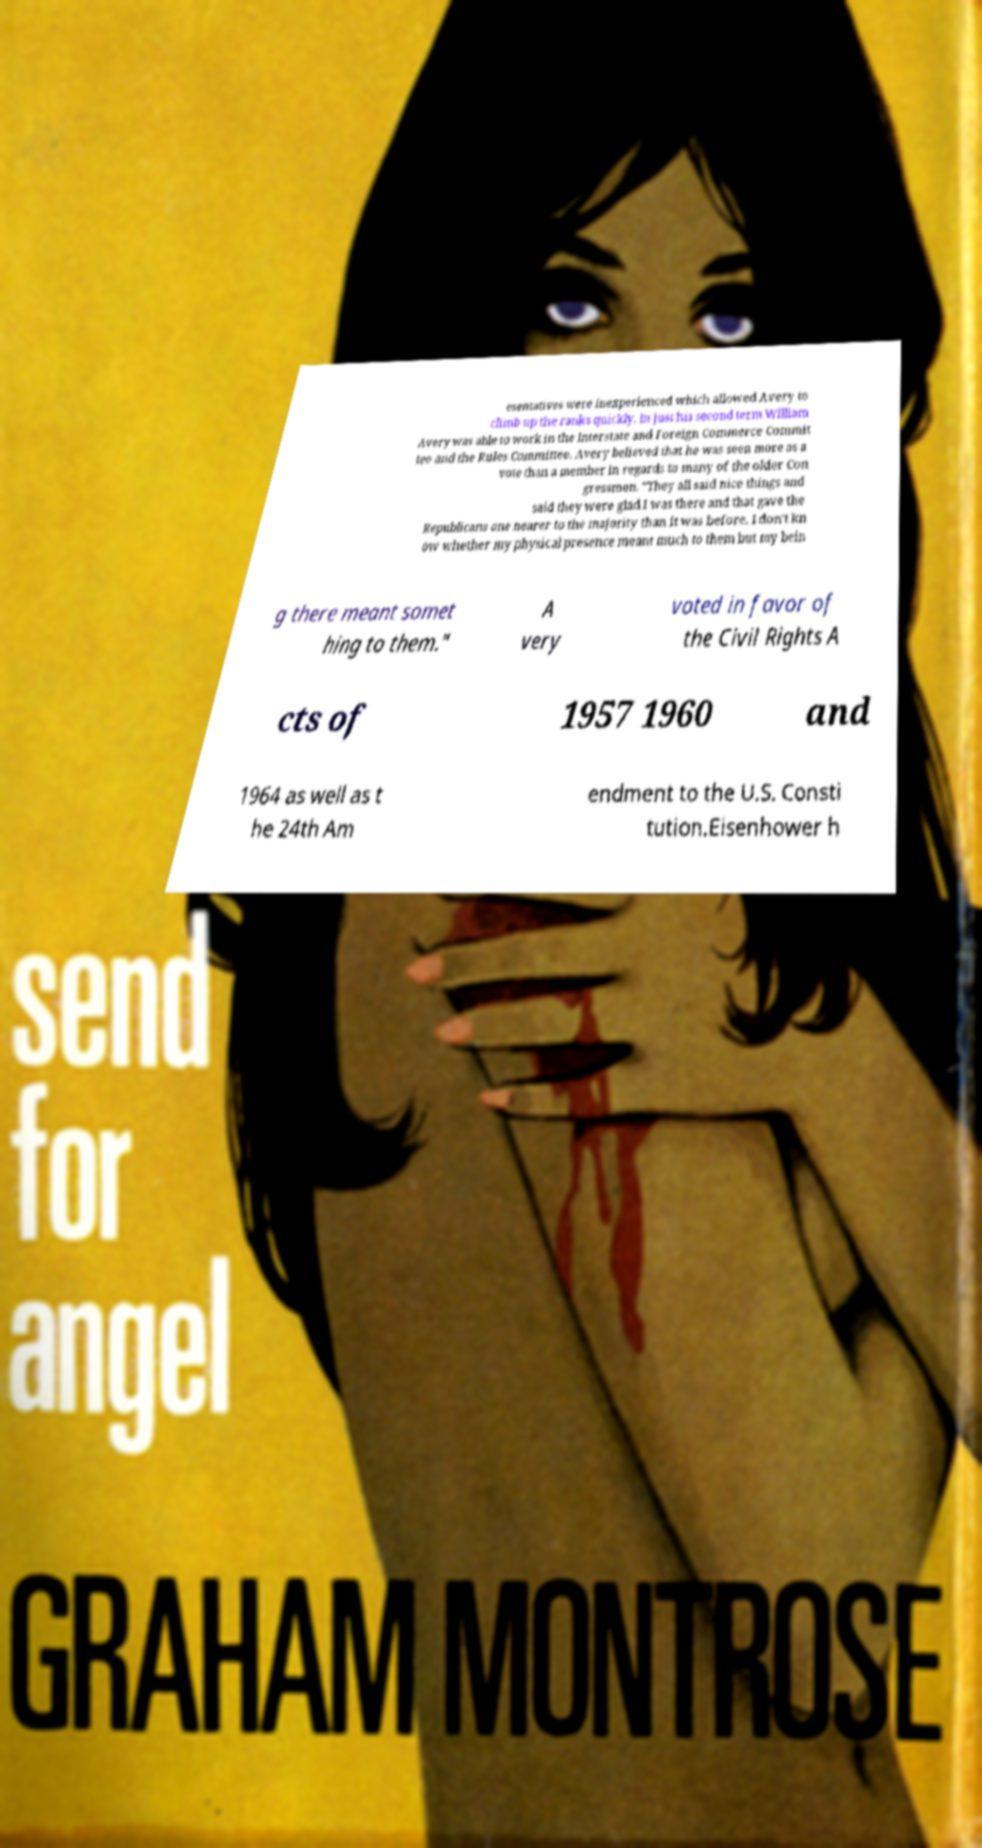There's text embedded in this image that I need extracted. Can you transcribe it verbatim? esentatives were inexperienced which allowed Avery to climb up the ranks quickly. In just his second term William Avery was able to work in the Interstate and Foreign Commerce Commit tee and the Rules Committee. Avery believed that he was seen more as a vote than a member in regards to many of the older Con gressmen. "They all said nice things and said they were glad I was there and that gave the Republicans one nearer to the majority than it was before. I don't kn ow whether my physical presence meant much to them but my bein g there meant somet hing to them." A very voted in favor of the Civil Rights A cts of 1957 1960 and 1964 as well as t he 24th Am endment to the U.S. Consti tution.Eisenhower h 